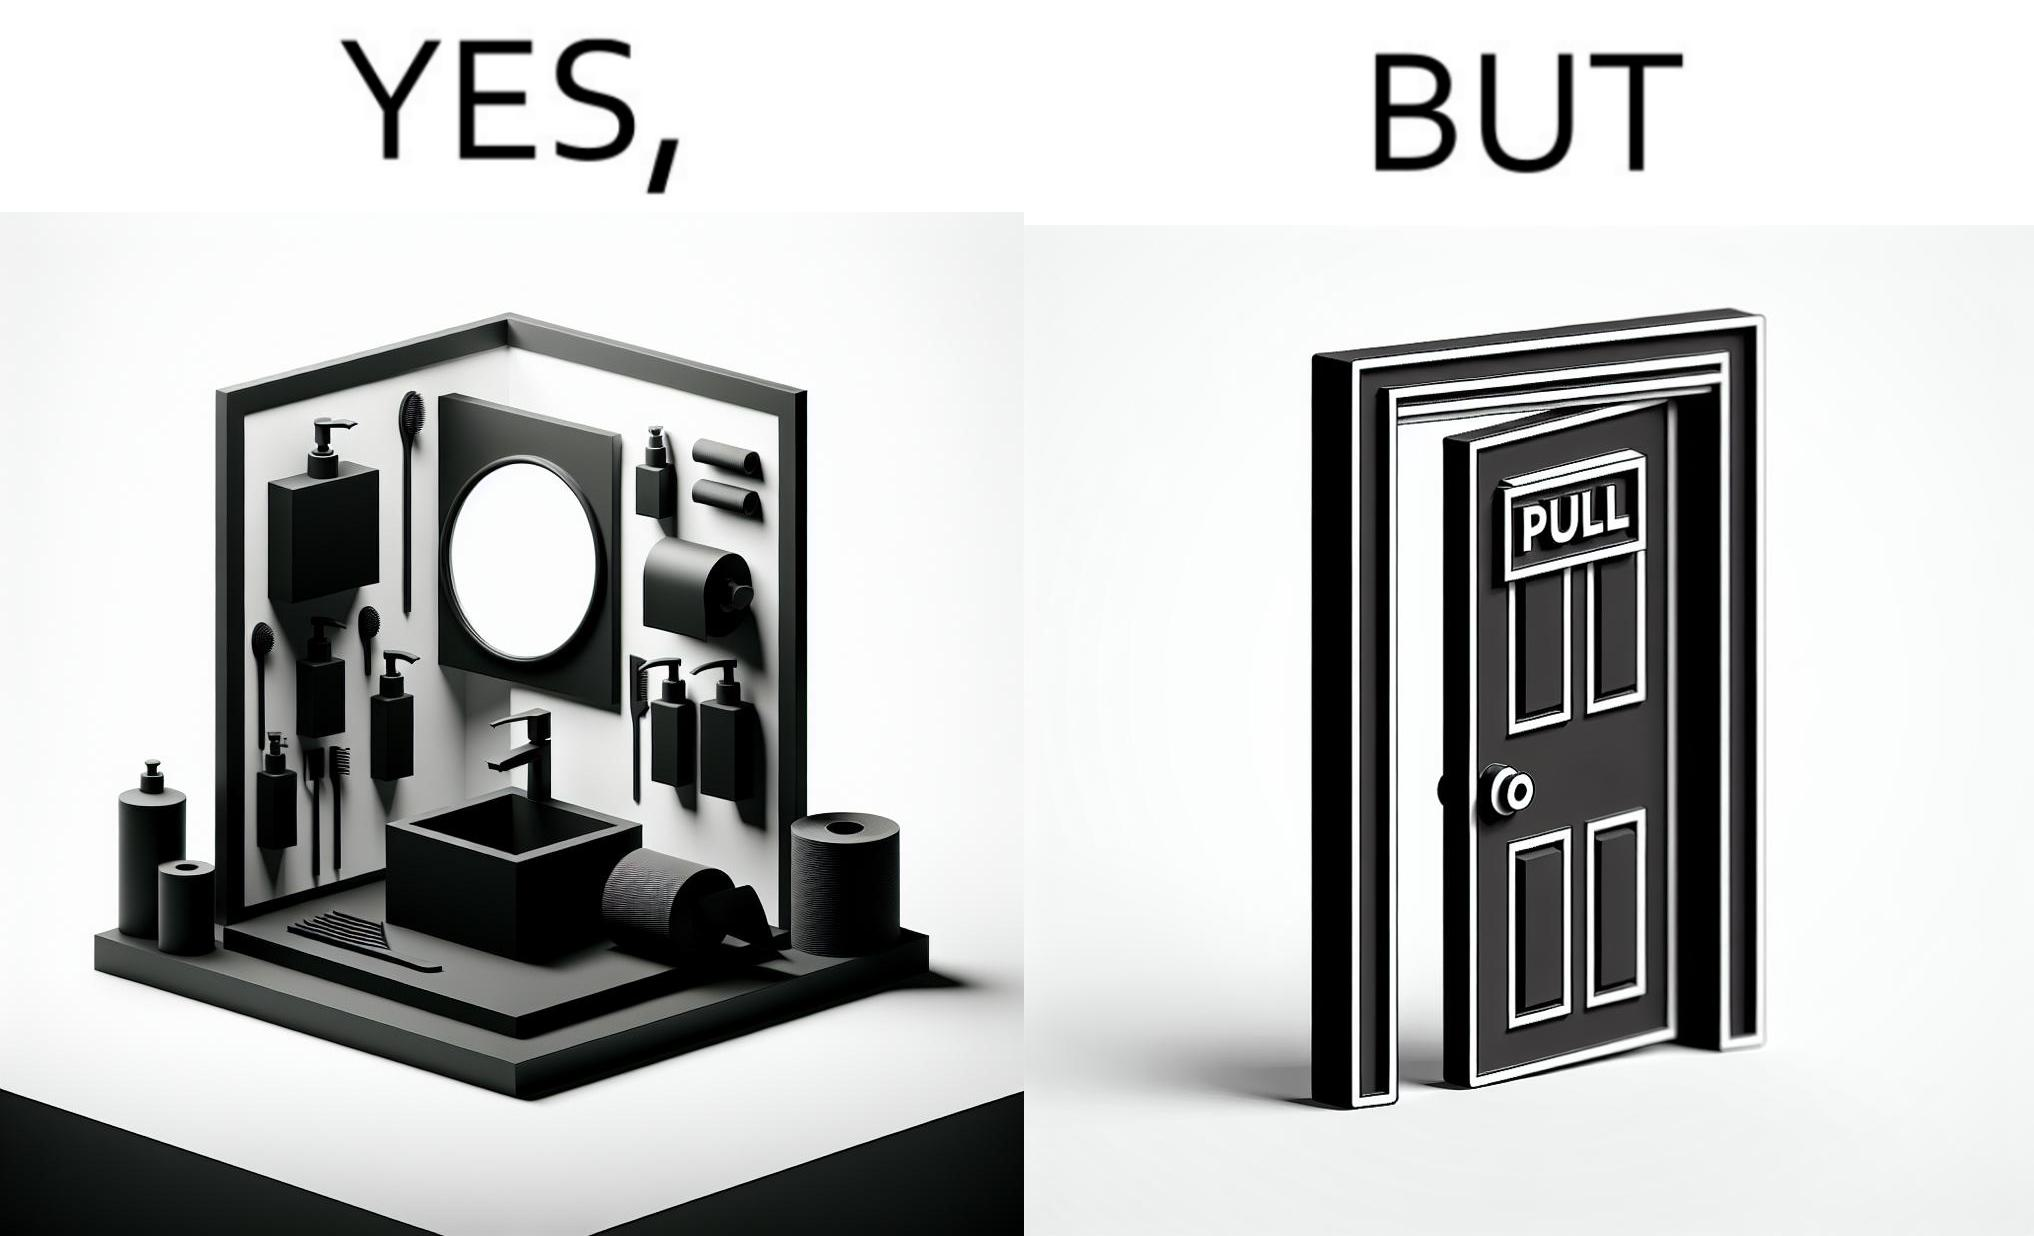What do you see in each half of this image? In the left part of the image: a basin with different handwashes and paper roll around it to clean hands with a mirror in front In the right part of the image: a door with a pull sign and handle on it 